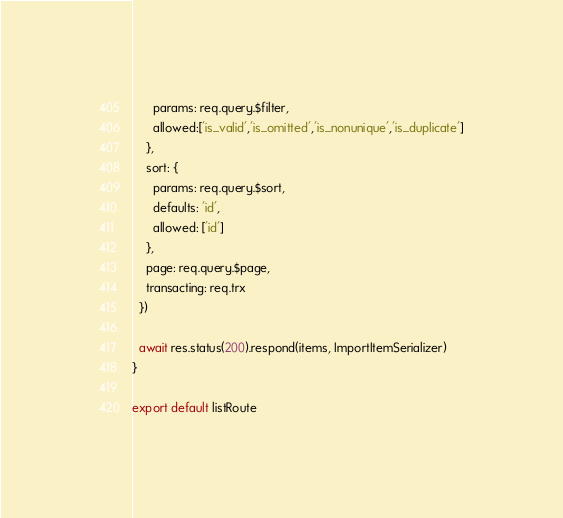Convert code to text. <code><loc_0><loc_0><loc_500><loc_500><_JavaScript_>      params: req.query.$filter,
      allowed:['is_valid','is_omitted','is_nonunique','is_duplicate']
    },
    sort: {
      params: req.query.$sort,
      defaults: 'id',
      allowed: ['id']
    },
    page: req.query.$page,
    transacting: req.trx
  })

  await res.status(200).respond(items, ImportItemSerializer)
}

export default listRoute
</code> 